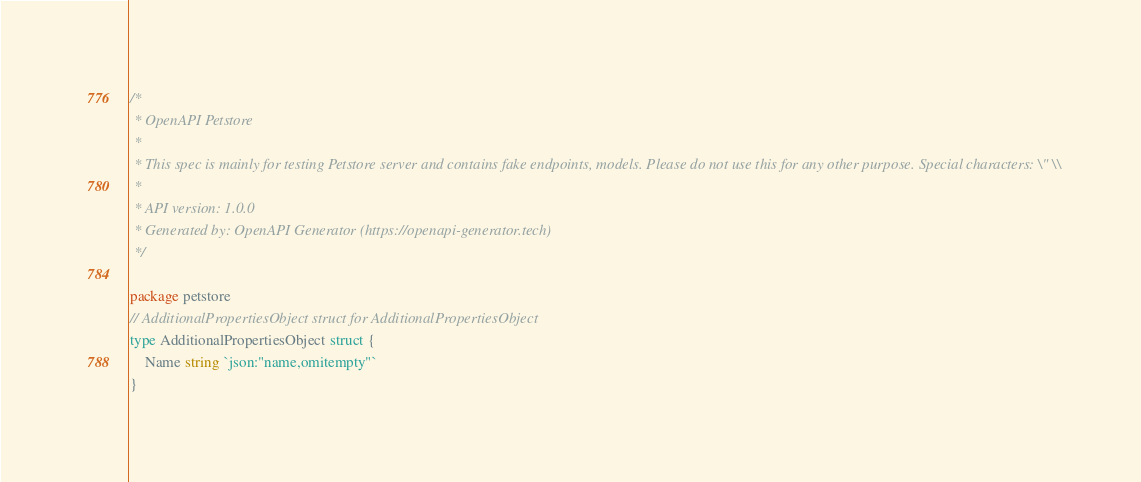Convert code to text. <code><loc_0><loc_0><loc_500><loc_500><_Go_>/*
 * OpenAPI Petstore
 *
 * This spec is mainly for testing Petstore server and contains fake endpoints, models. Please do not use this for any other purpose. Special characters: \" \\
 *
 * API version: 1.0.0
 * Generated by: OpenAPI Generator (https://openapi-generator.tech)
 */

package petstore
// AdditionalPropertiesObject struct for AdditionalPropertiesObject
type AdditionalPropertiesObject struct {
	Name string `json:"name,omitempty"`
}
</code> 